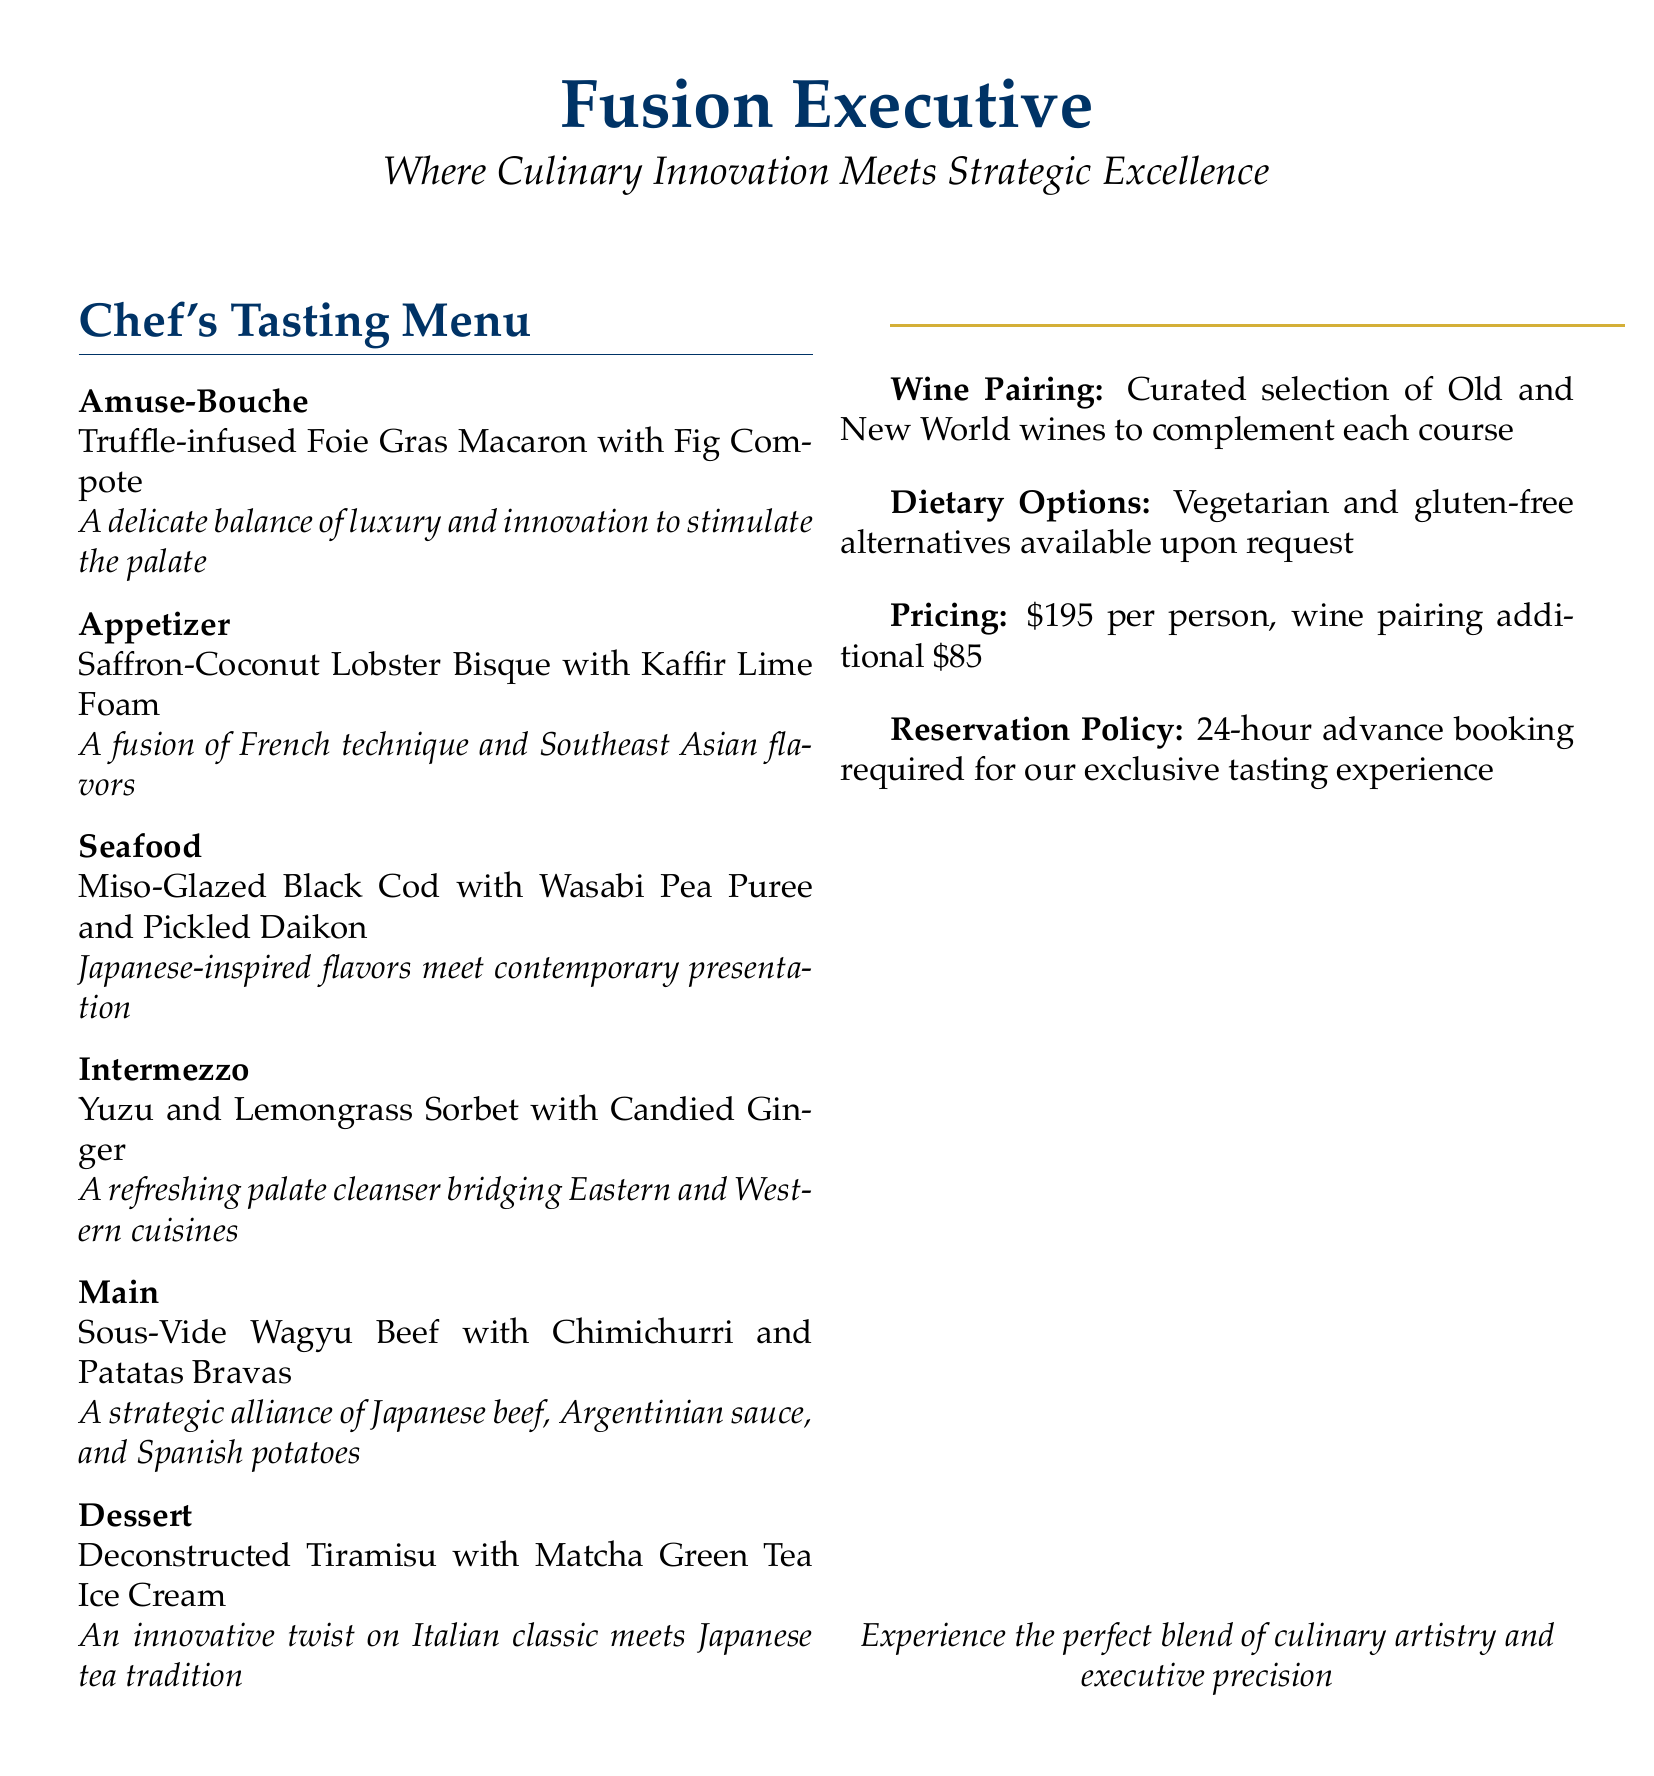What is the price of the Chef's Tasting Menu? The price is stated in the pricing section of the document, which is $195 per person.
Answer: $195 per person What type of cuisine is featured in the Amuse-Bouche? The Amuse-Bouche features luxury elements, specifically truffle and foie gras.
Answer: Luxury and innovation What is included in the wine pairing? The wine pairing consists of a curated selection of Old and New World wines tailored to each course.
Answer: Curated selection of Old and New World wines What is the main ingredient in the dessert? The dessert features Matcha Green Tea Ice Cream, indicating a fusion of Japanese tea tradition with an Italian classic.
Answer: Matcha Green Tea Ice Cream What dietary alternatives are available? The document mentions that vegetarian and gluten-free options are available upon request.
Answer: Vegetarian and gluten-free alternatives What is the required reservation notice for the tasting experience? The document states that a 24-hour advance booking is required for the exclusive tasting experience.
Answer: 24-hour advance booking How does the Main course incorporate international flavors? The Main course combines Japanese Wagyu beef, Argentinian chimichurri, and Spanish potatoes to create a fusion dish.
Answer: Japanese beef, Argentinian sauce, and Spanish potatoes What is served as an Intermezzo? The Intermezzo features a sorbet flavored with yuzu and lemongrass, indicating a refreshing cleanse that bridges two culinary traditions.
Answer: Yuzu and Lemongrass Sorbet with Candied Ginger 